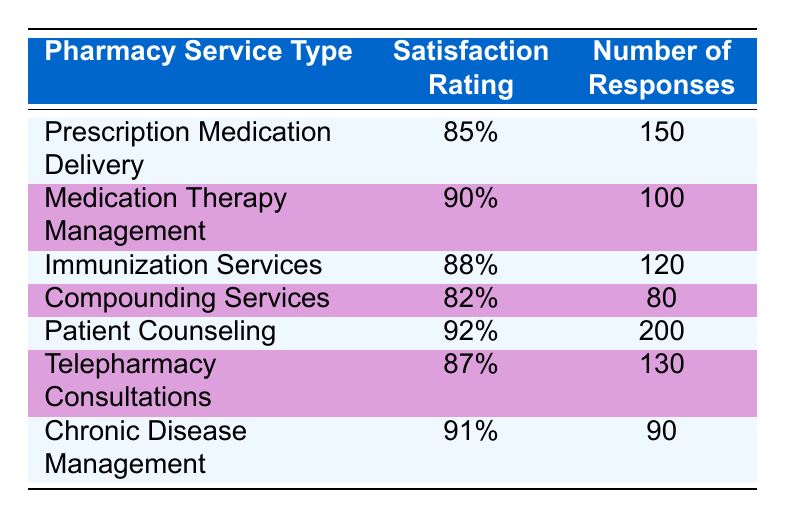What is the satisfaction rating for Patient Counseling? The table clearly lists the satisfaction rating for Patient Counseling as 92%.
Answer: 92% Which pharmacy service type has the highest satisfaction rating? By comparing the satisfaction ratings, Patient Counseling has the highest rating at 92%.
Answer: Patient Counseling How many total responses were recorded for Immunization Services and Compounding Services combined? The number of responses for Immunization Services is 120, and for Compounding Services, it's 80. Adding these gives 120 + 80 = 200 responses.
Answer: 200 Is the satisfaction rating for Telepharmacy Consultations above 85%? The table indicates a satisfaction rating of 87% for Telepharmacy Consultations, which is indeed above 85%.
Answer: Yes What is the average satisfaction rating across all the pharmacy service types listed? To find the average, sum the satisfaction ratings: 85 + 90 + 88 + 82 + 92 + 87 + 91 = 515. There are 7 services, so the average rating is 515/7 ≈ 73.57%.
Answer: 73.57% Are there more responses for Medication Therapy Management or Chronic Disease Management? Medication Therapy Management has 100 responses and Chronic Disease Management has 90 responses. Since 100 > 90, there are more responses for Medication Therapy Management.
Answer: Medication Therapy Management What is the difference in satisfaction ratings between Chronic Disease Management and Compounding Services? The satisfaction rating for Chronic Disease Management is 91% and for Compounding Services, it is 82%. The difference is calculated as 91 - 82 = 9%.
Answer: 9% Which two pharmacy service types had the closest satisfaction ratings? The satisfaction ratings are 90% (Medication Therapy Management) and 88% (Immunization Services), which are the closest with a difference of 2%.
Answer: Medication Therapy Management and Immunization Services Which service type received the least number of responses? Compounding Services has the least number of responses recorded at 80.
Answer: Compounding Services 